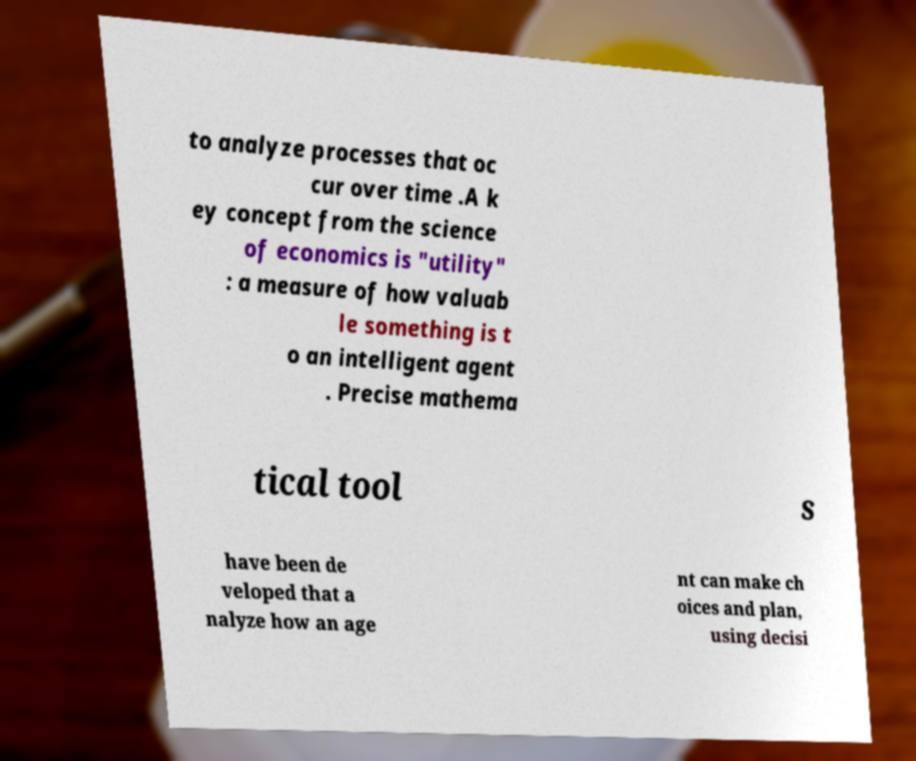Could you extract and type out the text from this image? to analyze processes that oc cur over time .A k ey concept from the science of economics is "utility" : a measure of how valuab le something is t o an intelligent agent . Precise mathema tical tool s have been de veloped that a nalyze how an age nt can make ch oices and plan, using decisi 